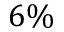<formula> <loc_0><loc_0><loc_500><loc_500>6 \%</formula> 